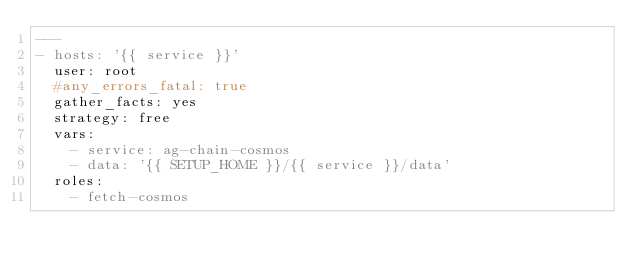Convert code to text. <code><loc_0><loc_0><loc_500><loc_500><_YAML_>---
- hosts: '{{ service }}'
  user: root
  #any_errors_fatal: true
  gather_facts: yes
  strategy: free
  vars:
    - service: ag-chain-cosmos
    - data: '{{ SETUP_HOME }}/{{ service }}/data'
  roles:
    - fetch-cosmos
</code> 